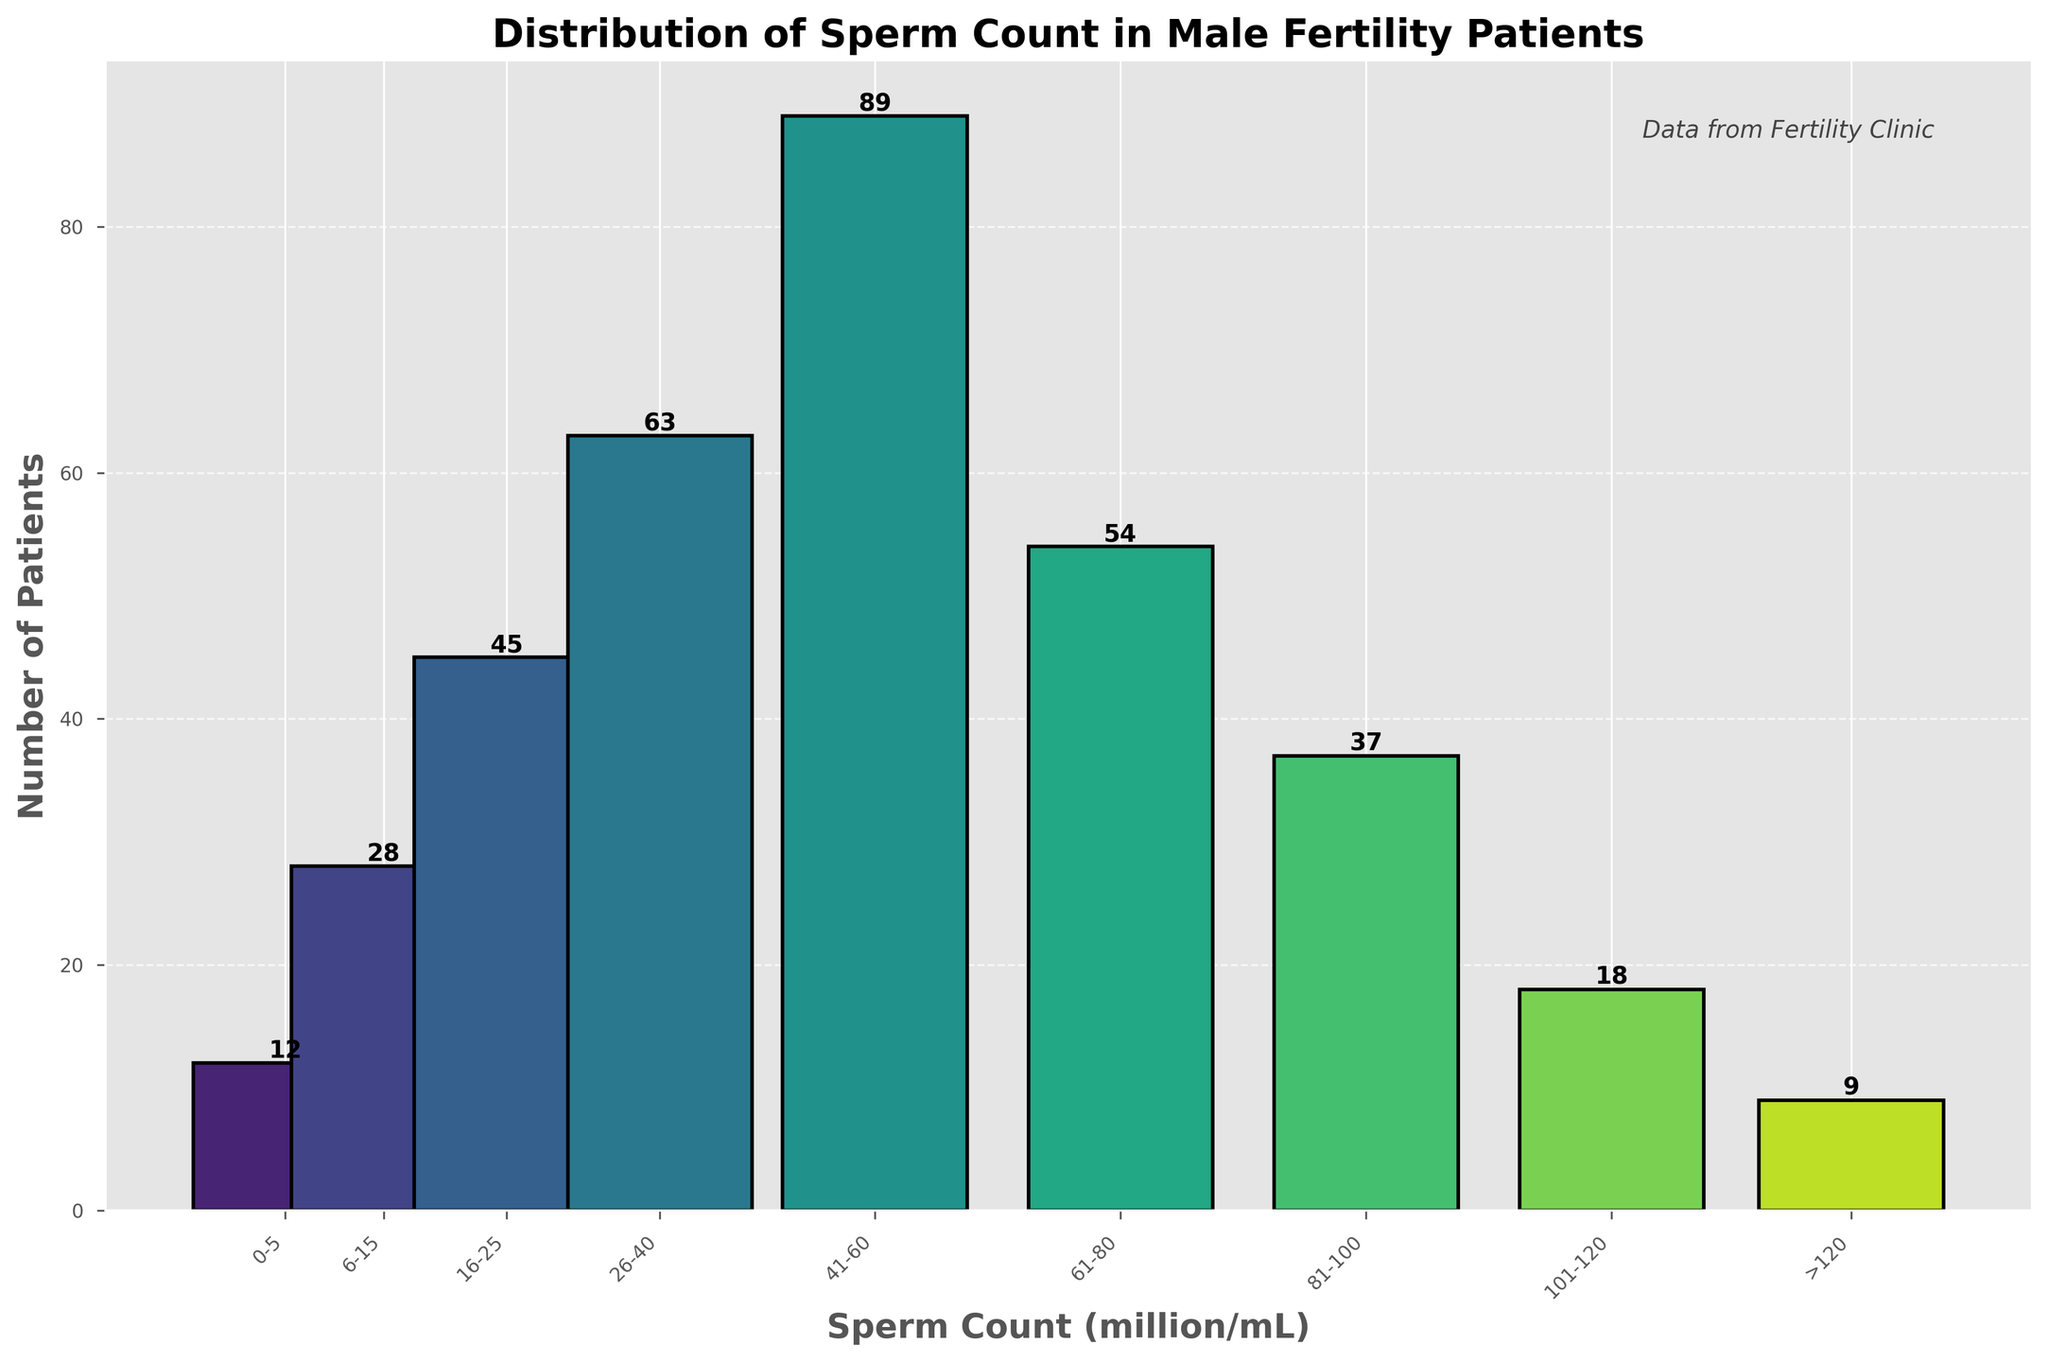Which sperm count range has the highest number of patients? The bar representing the sperm count range of 41-60 million/mL has the highest value in terms of patient count.
Answer: 41-60 million/mL What is the total number of patients with a sperm count higher than 100 million/mL? Sum the number of patients for the ranges 101-120 million/mL and >120 million/mL: 18 + 9 = 27.
Answer: 27 How many more patients fall in the 26-40 million/mL range compared to the 16-25 million/mL range? Subtract the number of patients in the 16-25 million/mL range (45) from the 26-40 million/mL range (63): 63 - 45 = 18.
Answer: 18 Which sperm count range has the lowest number of patients, and what is that number? The bar representing the sperm count range >120 million/mL is the shortest, with the number of patients being 9.
Answer: >120 million/mL, 9 How do the patient counts compare between the 6-15 million/mL and 61-80 million/mL sperm count ranges? The number of patients in the 6-15 million/mL range is 28, while in the 61-80 million/mL range, it is 54. Since 54 > 28, the 61-80 range has more patients.
Answer: 61-80 million/mL has more patients What is the sum of patients across all sperm count ranges? Add the number of patients in all ranges: 12 + 28 + 45 + 63 + 89 + 54 + 37 + 18 + 9 = 355.
Answer: 355 Which two adjacent sperm count ranges have the closest number of patients? The ranges 81-100 million/mL and 101-120 million/mL have 37 and 18 patients, respectively. The difference is 19, which is the smallest among adjacent ranges.
Answer: 81-100 million/mL and 101-120 million/mL What percentage of patients have a sperm count between 41-60 million/mL? Divide the number of patients in the 41-60 million/mL range by the total number of patients and multiply by 100: (89/355) * 100 ≈ 25.07%.
Answer: 25.07% How does the number of patients in the 0-5 million/mL range differ from those in the 81-100 million/mL range? Subtract the number of patients in the 0-5 million/mL range (12) from the 81-100 million/mL range (37): 37 - 12 = 25.
Answer: 25 